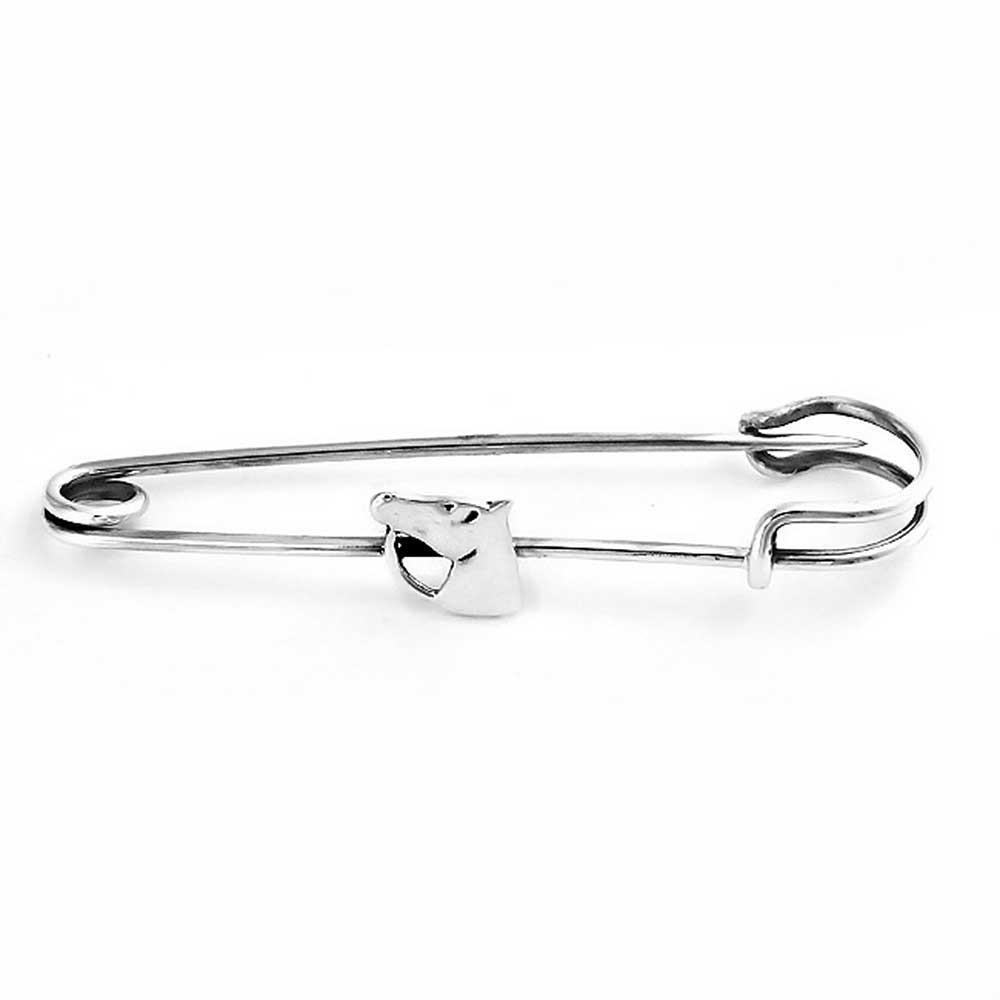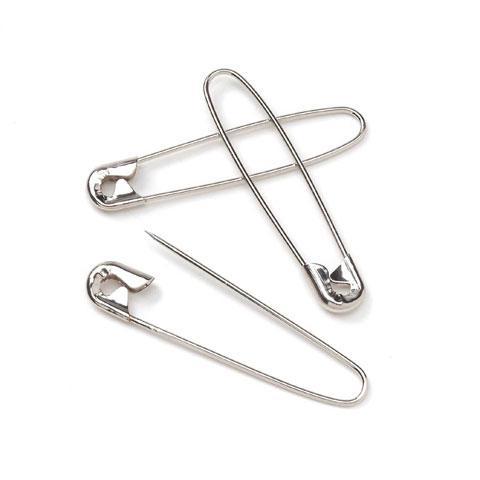The first image is the image on the left, the second image is the image on the right. Analyze the images presented: Is the assertion "An image shows exactly one safety pin, which is strung with a horse-head shape charm." valid? Answer yes or no. Yes. The first image is the image on the left, the second image is the image on the right. Given the left and right images, does the statement "One image shows exactly two pins and both of those pins are closed." hold true? Answer yes or no. No. 